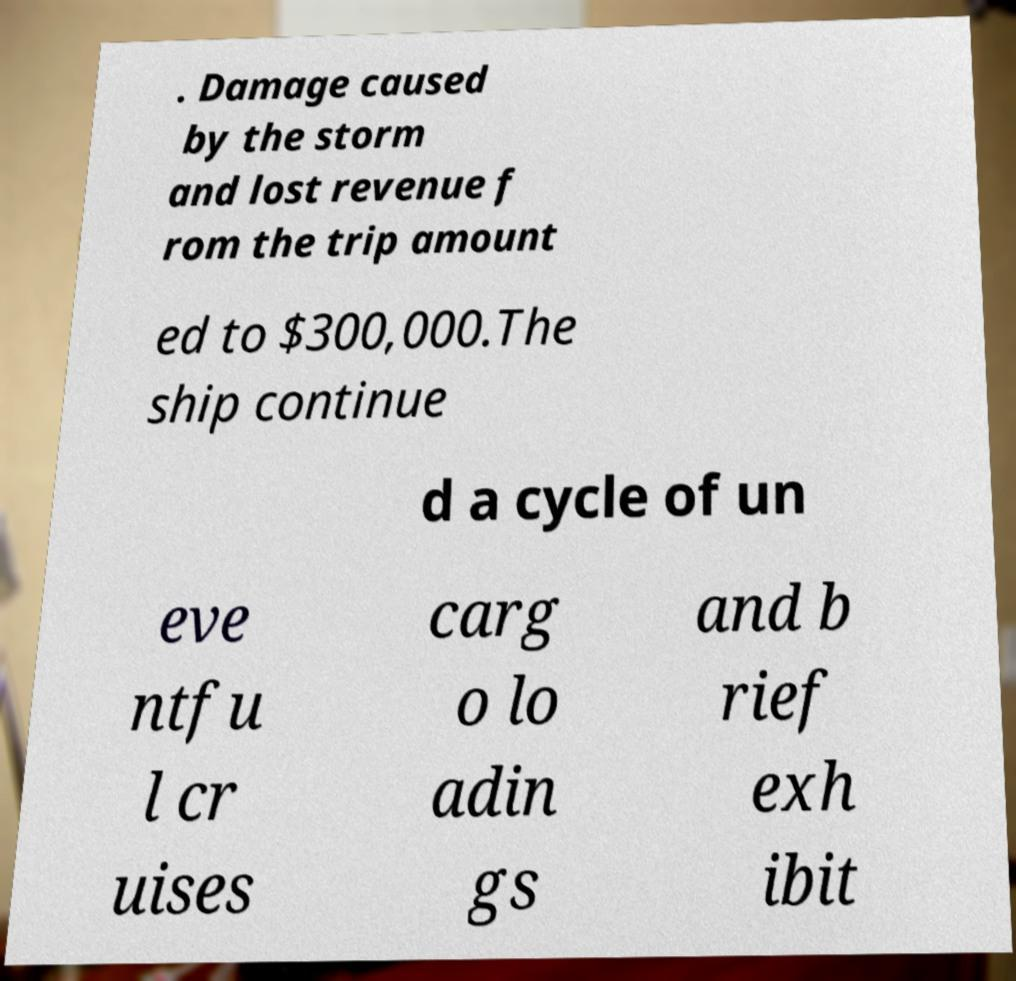Could you assist in decoding the text presented in this image and type it out clearly? . Damage caused by the storm and lost revenue f rom the trip amount ed to $300,000.The ship continue d a cycle of un eve ntfu l cr uises carg o lo adin gs and b rief exh ibit 